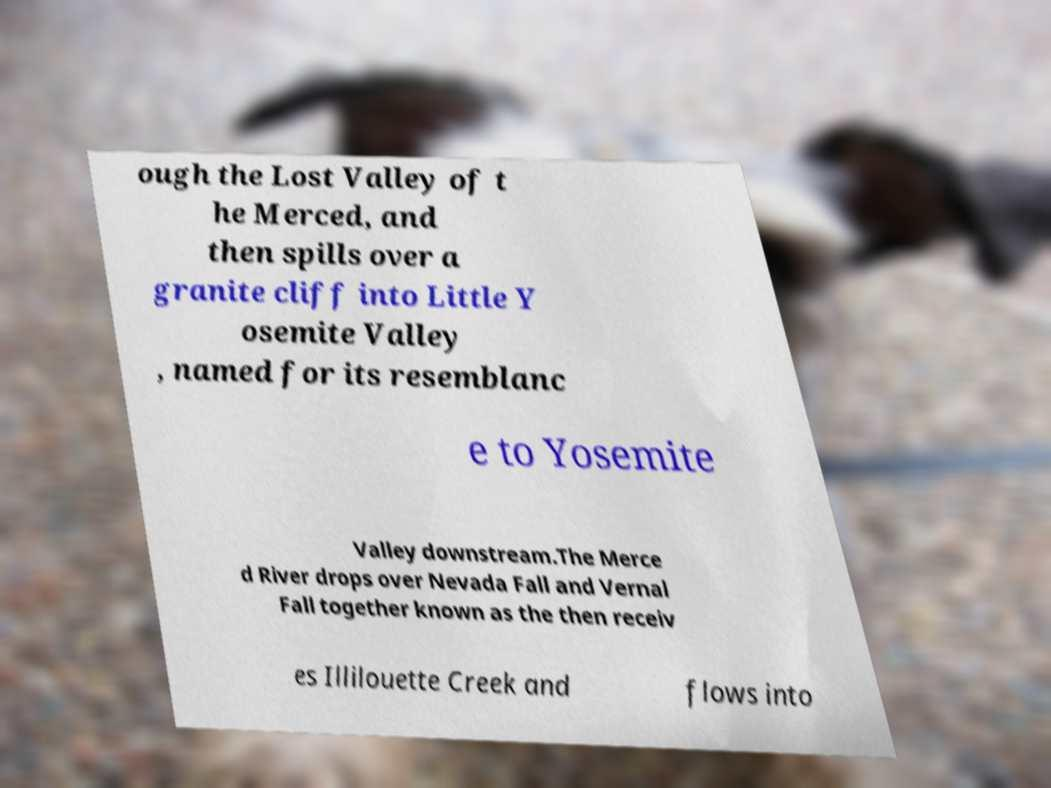There's text embedded in this image that I need extracted. Can you transcribe it verbatim? ough the Lost Valley of t he Merced, and then spills over a granite cliff into Little Y osemite Valley , named for its resemblanc e to Yosemite Valley downstream.The Merce d River drops over Nevada Fall and Vernal Fall together known as the then receiv es Illilouette Creek and flows into 